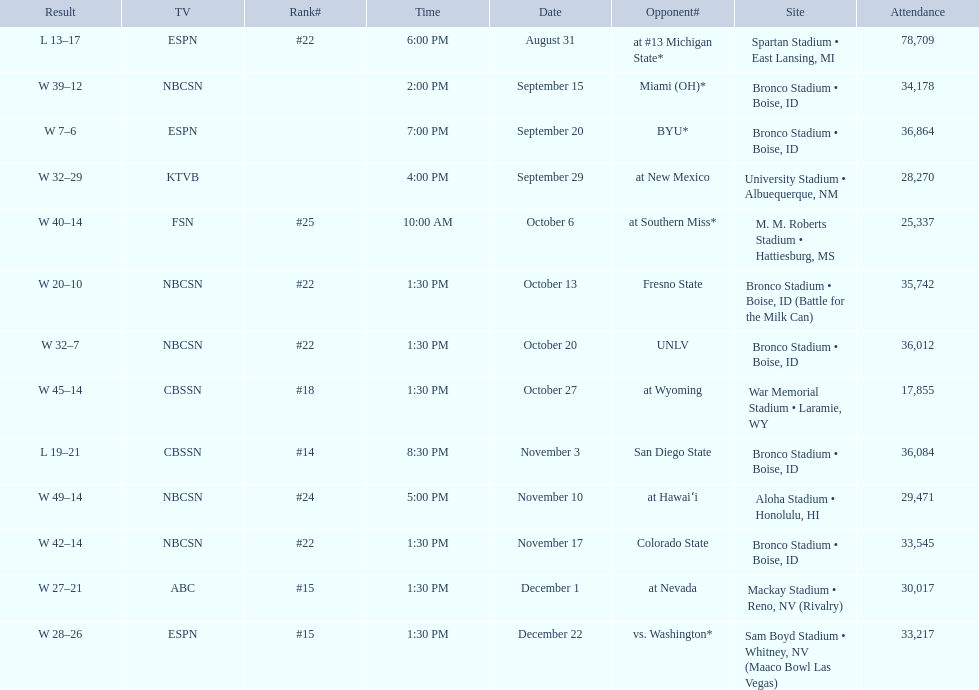What are the opponents to the  2012 boise state broncos football team? At #13 michigan state*, miami (oh)*, byu*, at new mexico, at southern miss*, fresno state, unlv, at wyoming, san diego state, at hawaiʻi, colorado state, at nevada, vs. washington*. Parse the full table in json format. {'header': ['Result', 'TV', 'Rank#', 'Time', 'Date', 'Opponent#', 'Site', 'Attendance'], 'rows': [['L\xa013–17', 'ESPN', '#22', '6:00 PM', 'August 31', 'at\xa0#13\xa0Michigan State*', 'Spartan Stadium • East Lansing, MI', '78,709'], ['W\xa039–12', 'NBCSN', '', '2:00 PM', 'September 15', 'Miami (OH)*', 'Bronco Stadium • Boise, ID', '34,178'], ['W\xa07–6', 'ESPN', '', '7:00 PM', 'September 20', 'BYU*', 'Bronco Stadium • Boise, ID', '36,864'], ['W\xa032–29', 'KTVB', '', '4:00 PM', 'September 29', 'at\xa0New Mexico', 'University Stadium • Albuequerque, NM', '28,270'], ['W\xa040–14', 'FSN', '#25', '10:00 AM', 'October 6', 'at\xa0Southern Miss*', 'M. M. Roberts Stadium • Hattiesburg, MS', '25,337'], ['W\xa020–10', 'NBCSN', '#22', '1:30 PM', 'October 13', 'Fresno State', 'Bronco Stadium • Boise, ID (Battle for the Milk Can)', '35,742'], ['W\xa032–7', 'NBCSN', '#22', '1:30 PM', 'October 20', 'UNLV', 'Bronco Stadium • Boise, ID', '36,012'], ['W\xa045–14', 'CBSSN', '#18', '1:30 PM', 'October 27', 'at\xa0Wyoming', 'War Memorial Stadium • Laramie, WY', '17,855'], ['L\xa019–21', 'CBSSN', '#14', '8:30 PM', 'November 3', 'San Diego State', 'Bronco Stadium • Boise, ID', '36,084'], ['W\xa049–14', 'NBCSN', '#24', '5:00 PM', 'November 10', 'at\xa0Hawaiʻi', 'Aloha Stadium • Honolulu, HI', '29,471'], ['W\xa042–14', 'NBCSN', '#22', '1:30 PM', 'November 17', 'Colorado State', 'Bronco Stadium • Boise, ID', '33,545'], ['W\xa027–21', 'ABC', '#15', '1:30 PM', 'December 1', 'at\xa0Nevada', 'Mackay Stadium • Reno, NV (Rivalry)', '30,017'], ['W\xa028–26', 'ESPN', '#15', '1:30 PM', 'December 22', 'vs.\xa0Washington*', 'Sam Boyd Stadium • Whitney, NV (Maaco Bowl Las Vegas)', '33,217']]} Which is the highest ranked of the teams? San Diego State. 